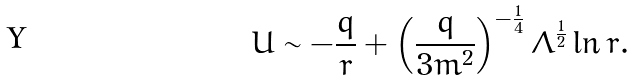Convert formula to latex. <formula><loc_0><loc_0><loc_500><loc_500>U \sim - \frac { q } { r } + \left ( \frac { q } { 3 m ^ { 2 } } \right ) ^ { - \frac { 1 } { 4 } } \Lambda ^ { \frac { 1 } { 2 } } \ln r .</formula> 